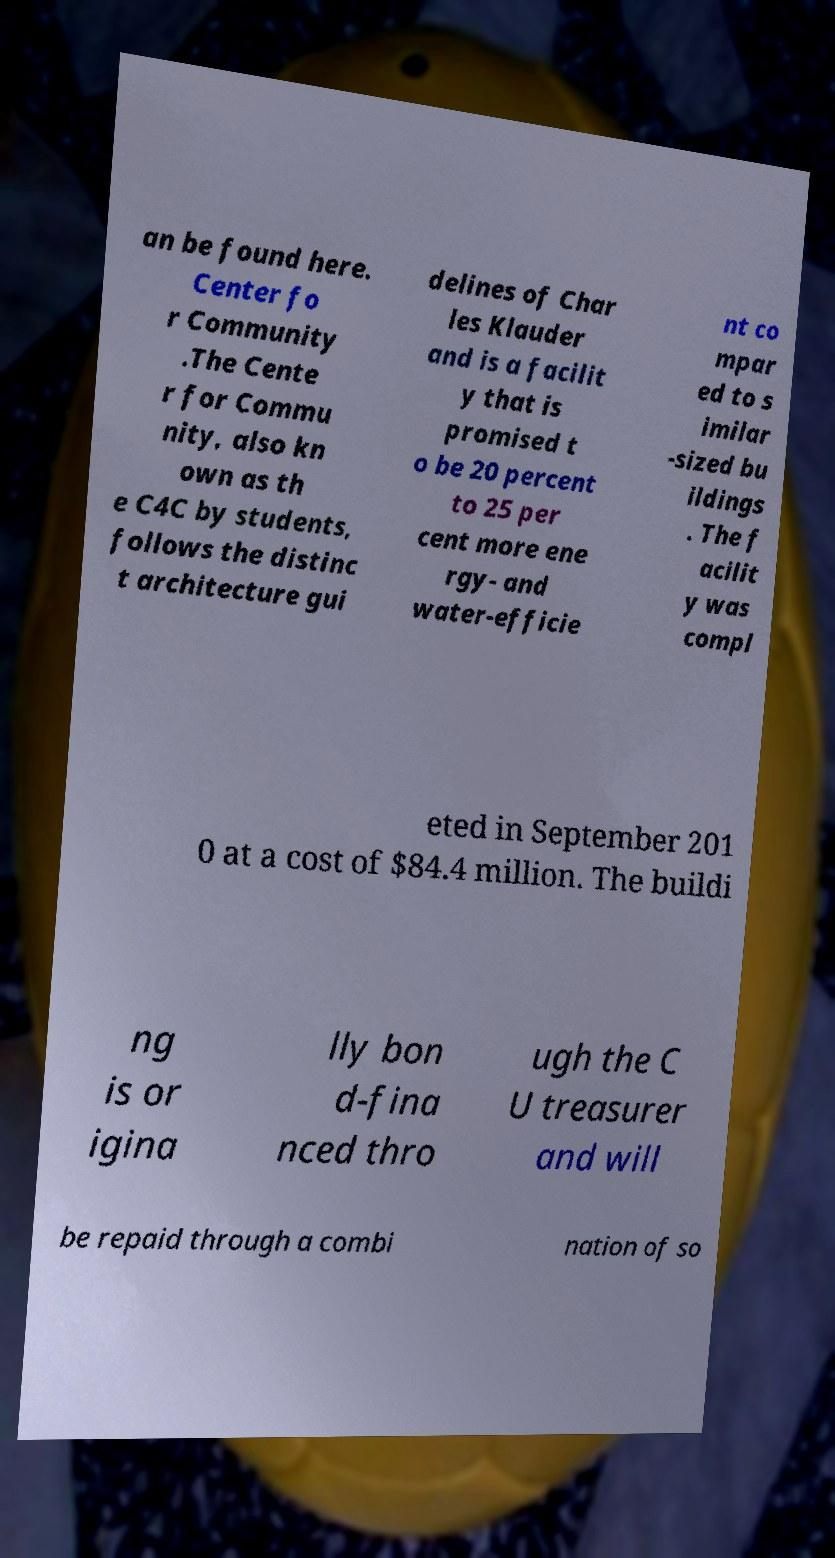For documentation purposes, I need the text within this image transcribed. Could you provide that? an be found here. Center fo r Community .The Cente r for Commu nity, also kn own as th e C4C by students, follows the distinc t architecture gui delines of Char les Klauder and is a facilit y that is promised t o be 20 percent to 25 per cent more ene rgy- and water-efficie nt co mpar ed to s imilar -sized bu ildings . The f acilit y was compl eted in September 201 0 at a cost of $84.4 million. The buildi ng is or igina lly bon d-fina nced thro ugh the C U treasurer and will be repaid through a combi nation of so 